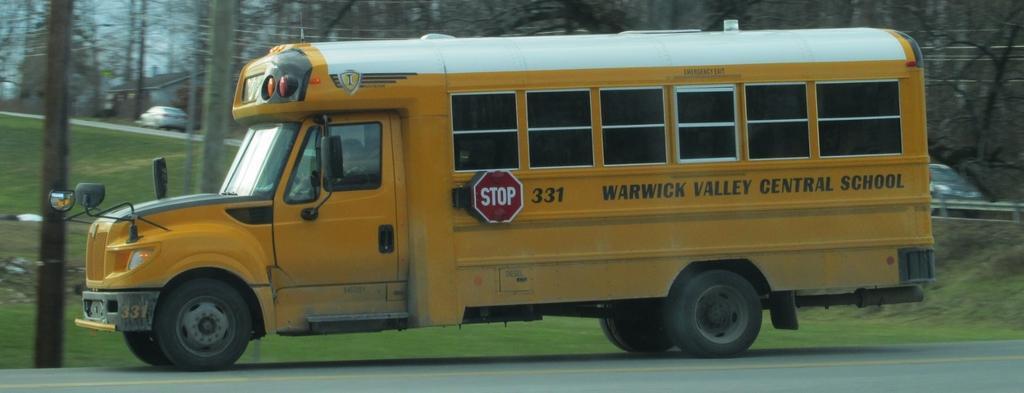Please provide a concise description of this image. Here in this picture we can see a yellow bus present on the road over there and we can also see pole here and there and we can see cars, trees and plants present all over there. 